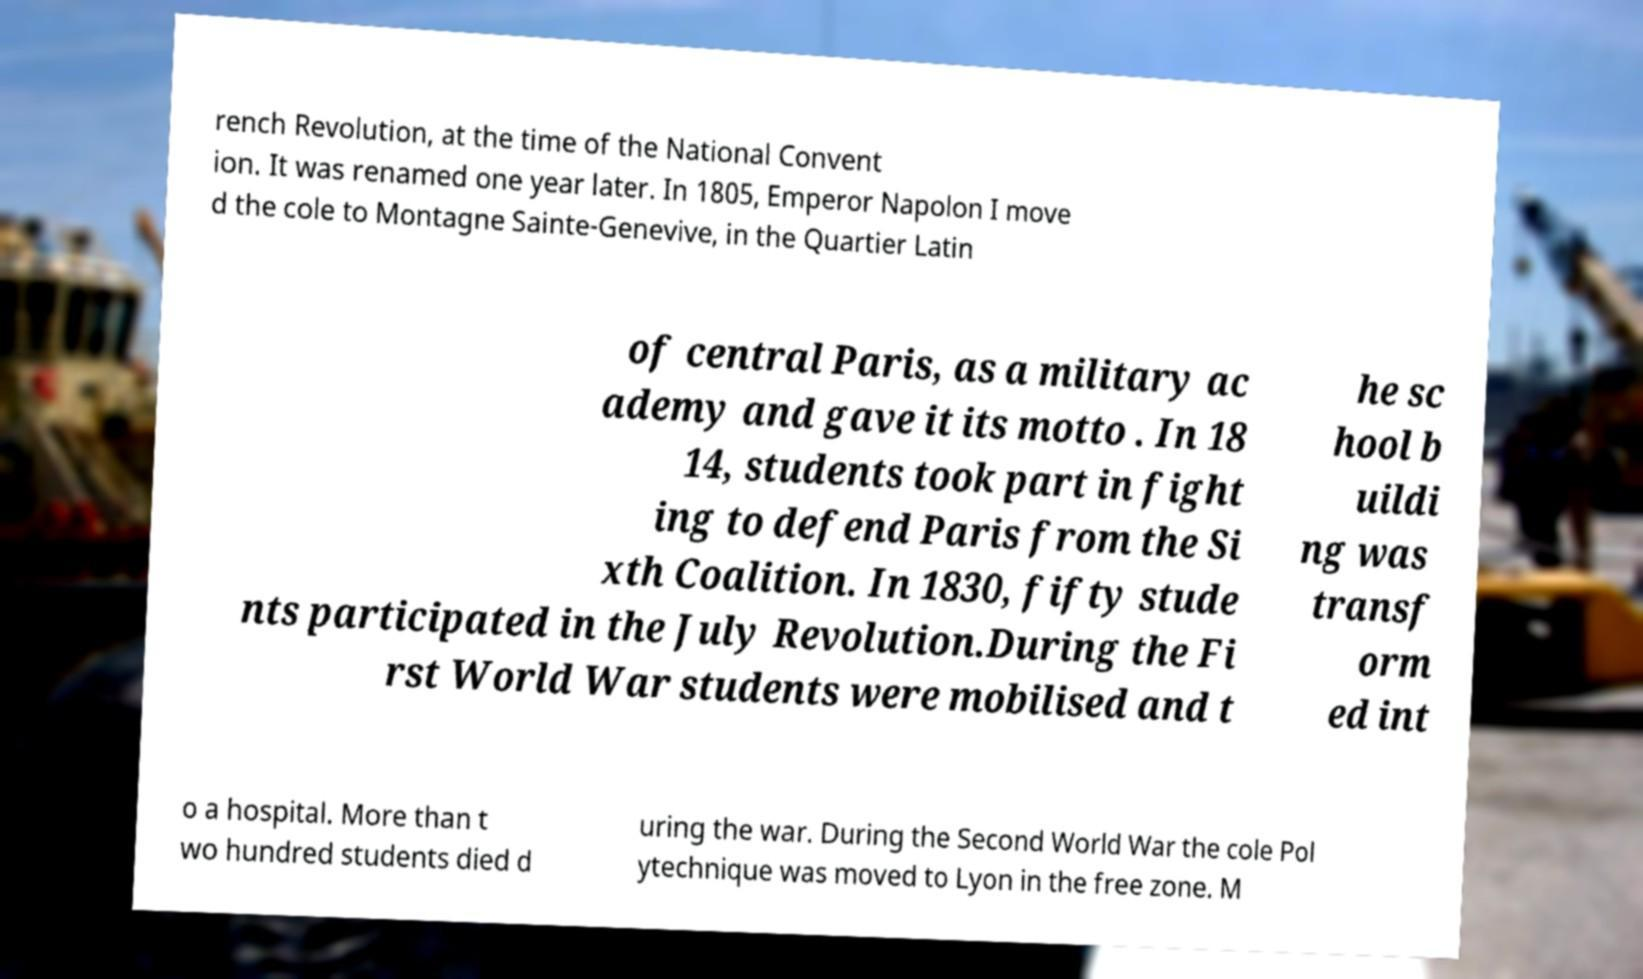Could you assist in decoding the text presented in this image and type it out clearly? rench Revolution, at the time of the National Convent ion. It was renamed one year later. In 1805, Emperor Napolon I move d the cole to Montagne Sainte-Genevive, in the Quartier Latin of central Paris, as a military ac ademy and gave it its motto . In 18 14, students took part in fight ing to defend Paris from the Si xth Coalition. In 1830, fifty stude nts participated in the July Revolution.During the Fi rst World War students were mobilised and t he sc hool b uildi ng was transf orm ed int o a hospital. More than t wo hundred students died d uring the war. During the Second World War the cole Pol ytechnique was moved to Lyon in the free zone. M 